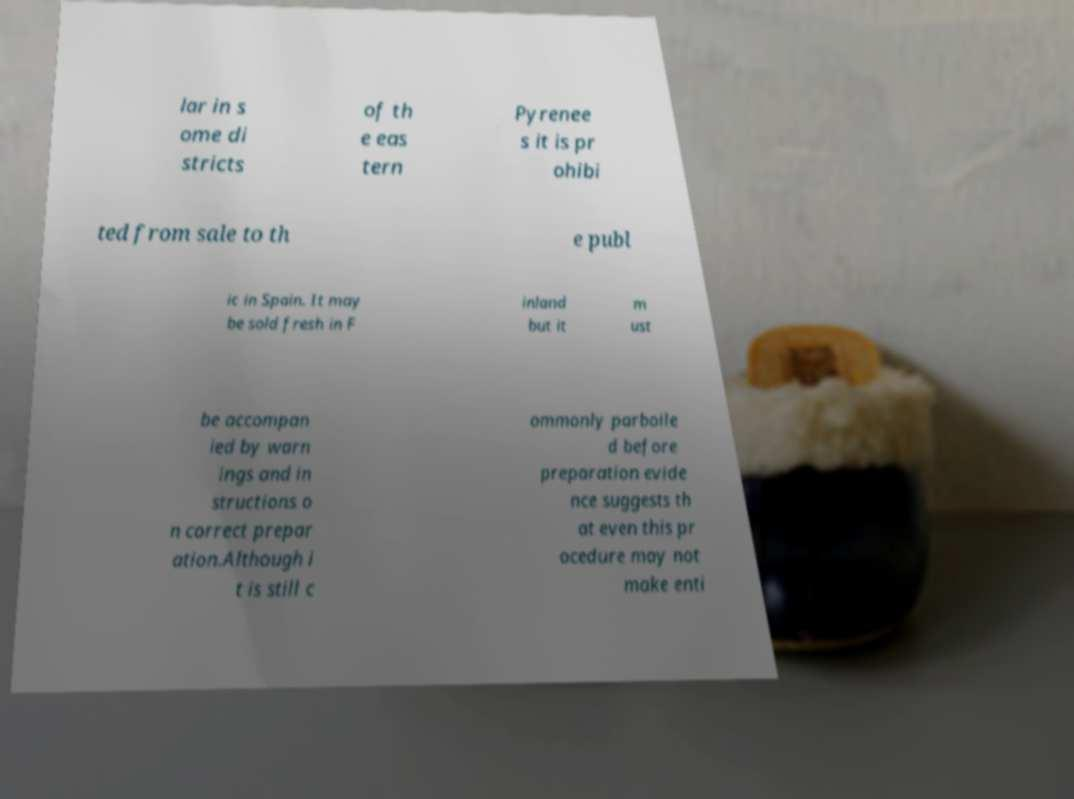I need the written content from this picture converted into text. Can you do that? lar in s ome di stricts of th e eas tern Pyrenee s it is pr ohibi ted from sale to th e publ ic in Spain. It may be sold fresh in F inland but it m ust be accompan ied by warn ings and in structions o n correct prepar ation.Although i t is still c ommonly parboile d before preparation evide nce suggests th at even this pr ocedure may not make enti 